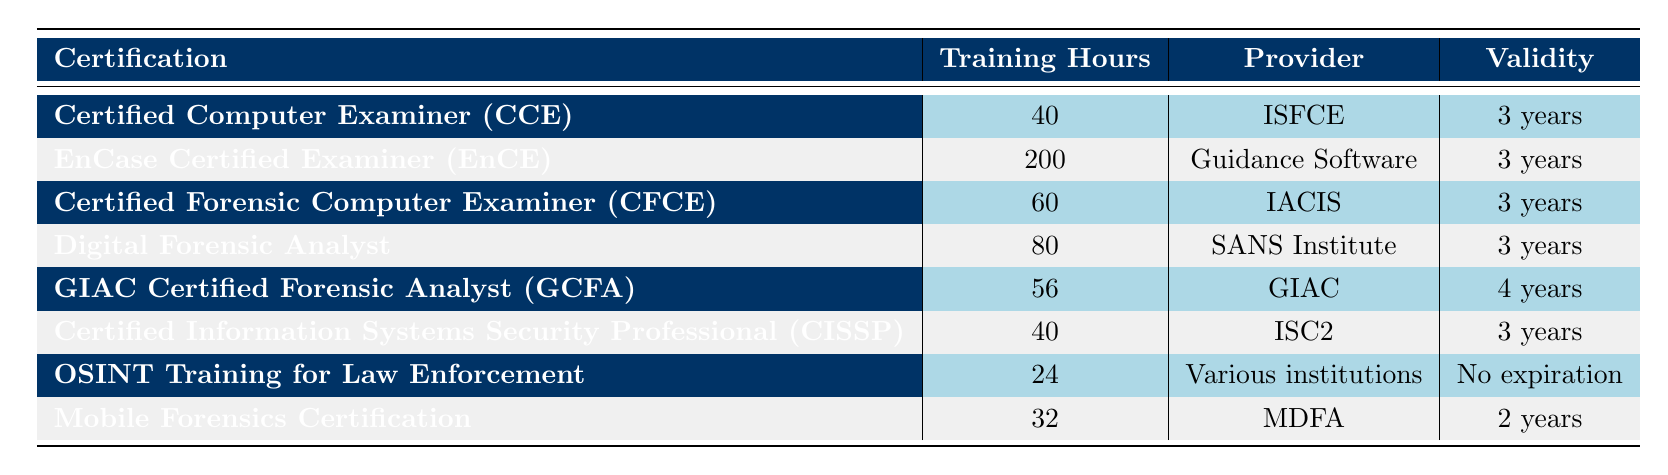What is the provider for the Certified Information Systems Security Professional (CISSP)? The table indicates that the provider for CISSP is ISC2.
Answer: ISC2 How many training hours are needed for the EnCase Certified Examiner (EnCE)? According to the table, the training hours required for EnCE are 200.
Answer: 200 Which certification has the shortest validity period? The table shows the certifications with their respective validity periods. OSINT Training for Law Enforcement has no expiration, while the others have a validity period of 2, 3, or 4 years. Therefore, it is not the shortest. The shortest validity is 2 years for Mobile Forensics Certification.
Answer: 2 years Which certification requires the most training hours? By comparing the training hours listed, EnCase Certified Examiner (EnCE) requires the most at 200 hours.
Answer: 200 hours What is the average training hour requirement for the certifications listed? To find the average, sum up all training hours: (40 + 200 + 60 + 80 + 56 + 40 + 24 + 32) = 532. There are 8 certifications, so the average is 532 / 8 = 66.5.
Answer: 66.5 Is the Digital Forensic Analyst certification valid for more than 3 years? The table states that the validity for the Digital Forensic Analyst certification is 3 years, so it is not valid for more than that.
Answer: No How many certifications have a validity period of 3 years? By inspecting the validity column, we see that 5 certifications have a validity period of 3 years.
Answer: 5 Which provider issues the certification with the second highest training hours? The certification with the second highest training hours is Digital Forensic Analyst with 80 hours, provided by SANS Institute.
Answer: SANS Institute What is the difference in training hours between the certification with the highest and the lowest training hours? The highest training hour certification is EnCase Certified Examiner (200 hours) and the lowest is OSINT Training for Law Enforcement (24 hours). The difference is 200 - 24 = 176 hours.
Answer: 176 hours 